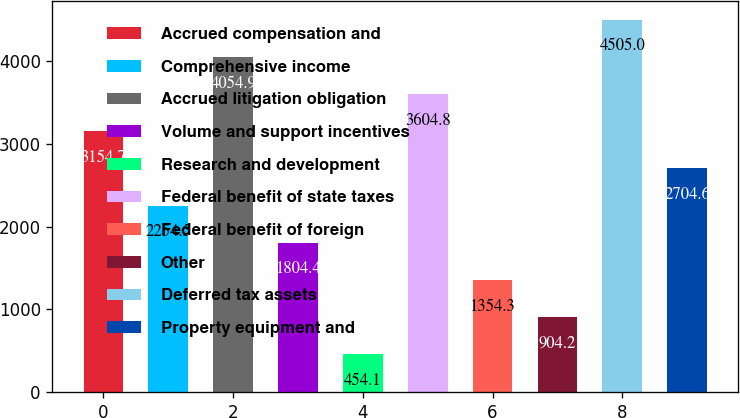Convert chart. <chart><loc_0><loc_0><loc_500><loc_500><bar_chart><fcel>Accrued compensation and<fcel>Comprehensive income<fcel>Accrued litigation obligation<fcel>Volume and support incentives<fcel>Research and development<fcel>Federal benefit of state taxes<fcel>Federal benefit of foreign<fcel>Other<fcel>Deferred tax assets<fcel>Property equipment and<nl><fcel>3154.7<fcel>2254.5<fcel>4054.9<fcel>1804.4<fcel>454.1<fcel>3604.8<fcel>1354.3<fcel>904.2<fcel>4505<fcel>2704.6<nl></chart> 